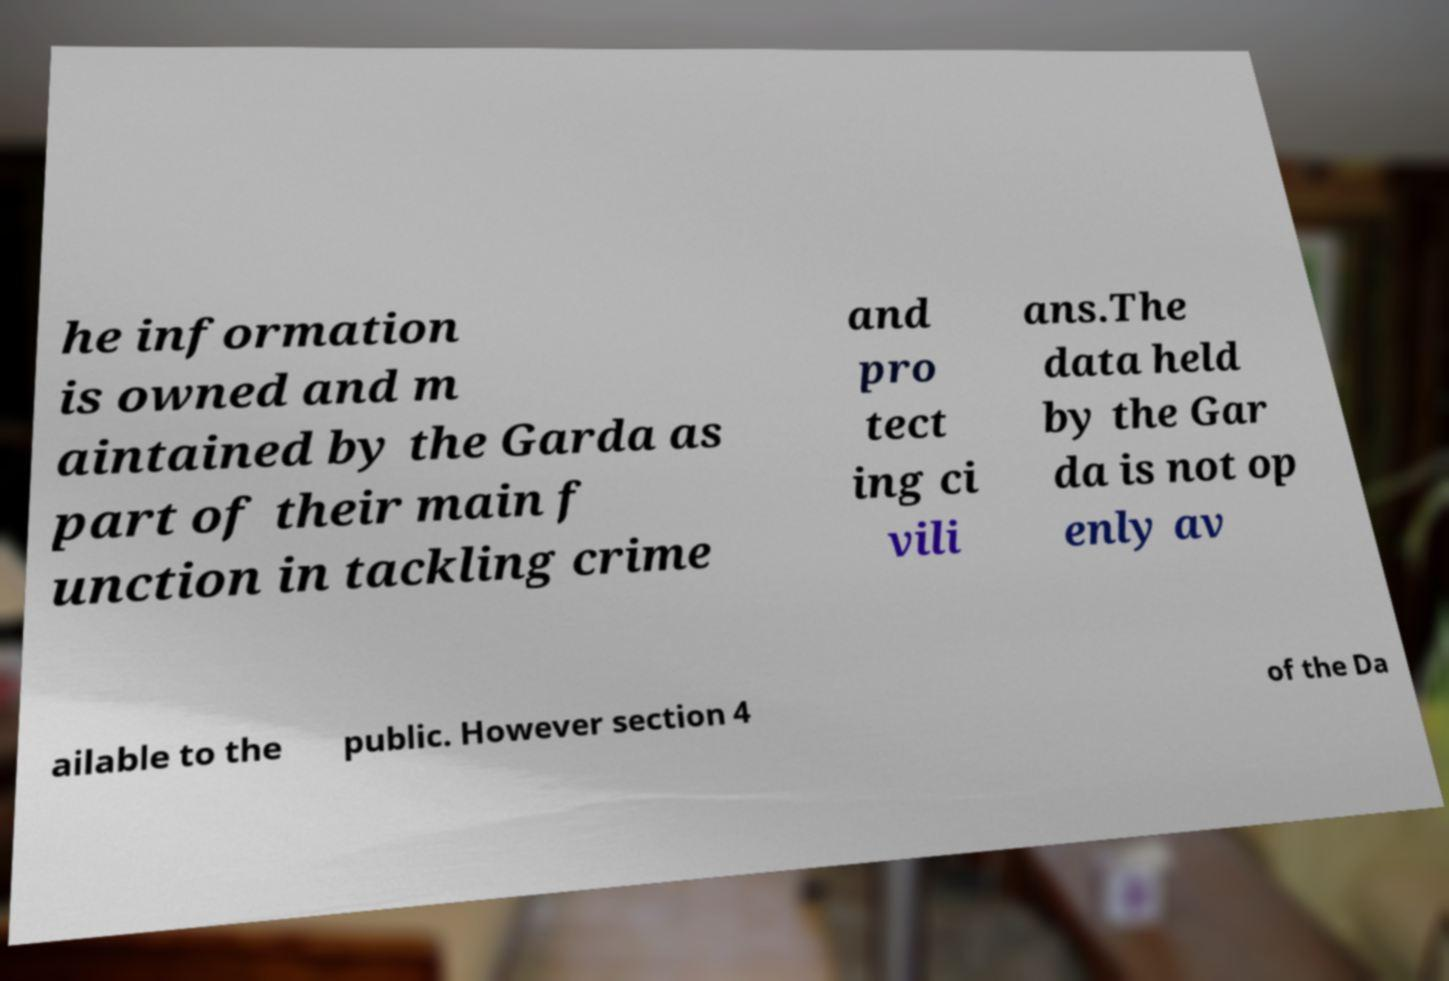Could you extract and type out the text from this image? he information is owned and m aintained by the Garda as part of their main f unction in tackling crime and pro tect ing ci vili ans.The data held by the Gar da is not op enly av ailable to the public. However section 4 of the Da 